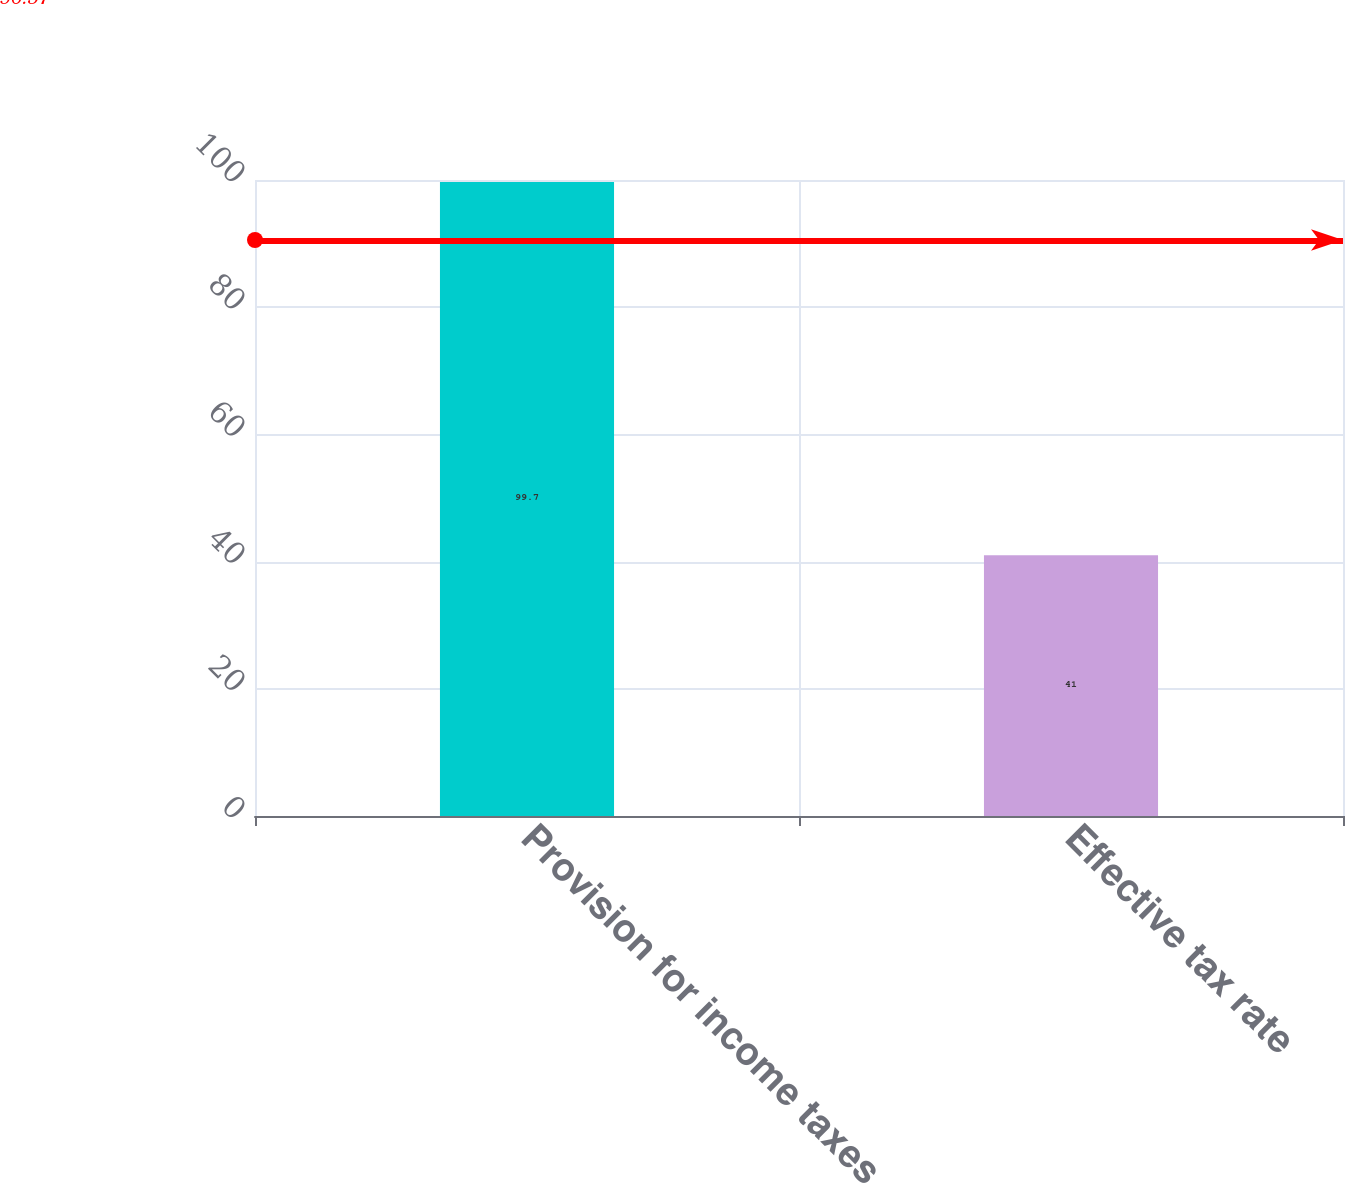<chart> <loc_0><loc_0><loc_500><loc_500><bar_chart><fcel>Provision for income taxes<fcel>Effective tax rate<nl><fcel>99.7<fcel>41<nl></chart> 